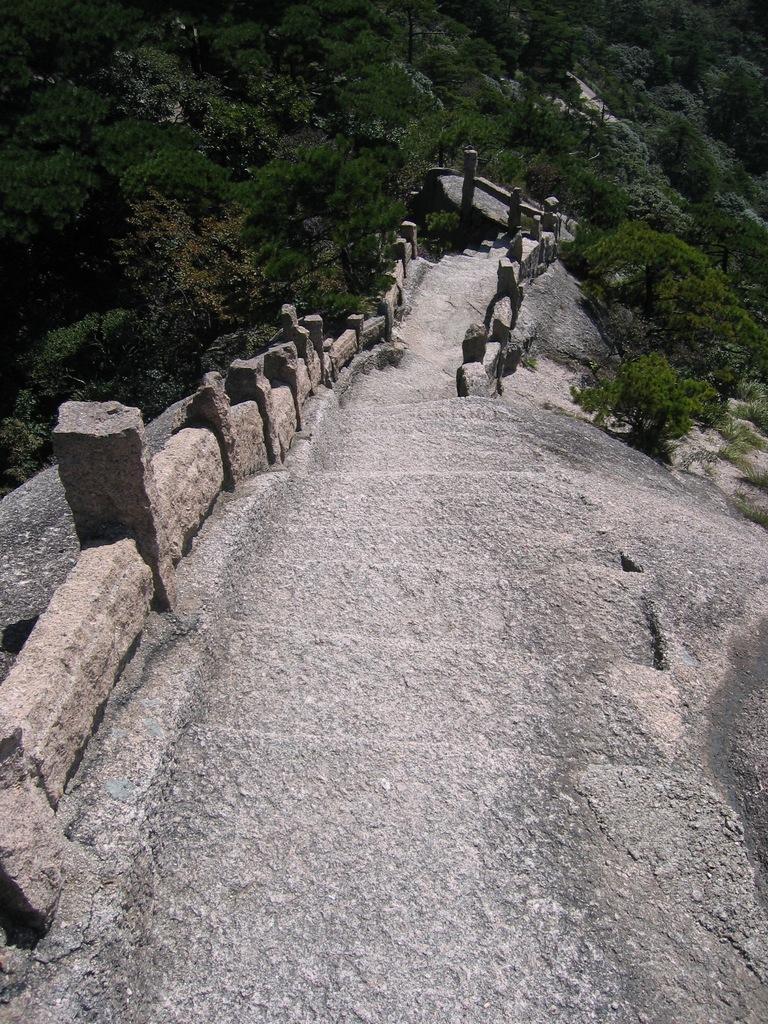How would you summarize this image in a sentence or two? In this image there is a path in the middle and there are stones on either side of the path. In the background there are trees. 